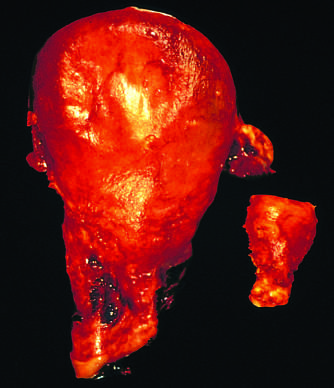what was removed for postpartum bleeding?
Answer the question using a single word or phrase. A gravid uterus 